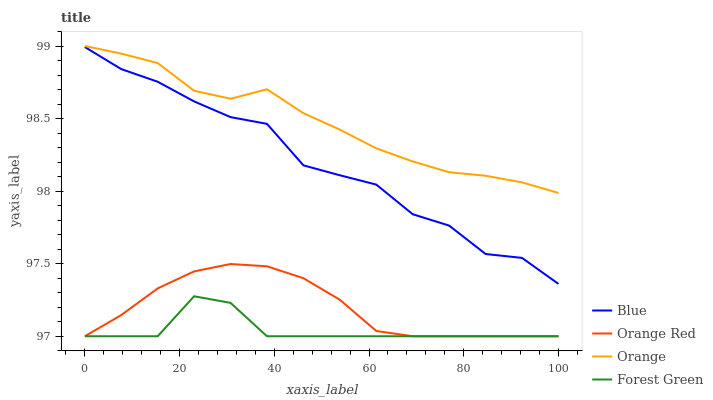Does Orange have the minimum area under the curve?
Answer yes or no. No. Does Forest Green have the maximum area under the curve?
Answer yes or no. No. Is Orange the smoothest?
Answer yes or no. No. Is Orange the roughest?
Answer yes or no. No. Does Orange have the lowest value?
Answer yes or no. No. Does Forest Green have the highest value?
Answer yes or no. No. Is Blue less than Orange?
Answer yes or no. Yes. Is Orange greater than Orange Red?
Answer yes or no. Yes. Does Blue intersect Orange?
Answer yes or no. No. 